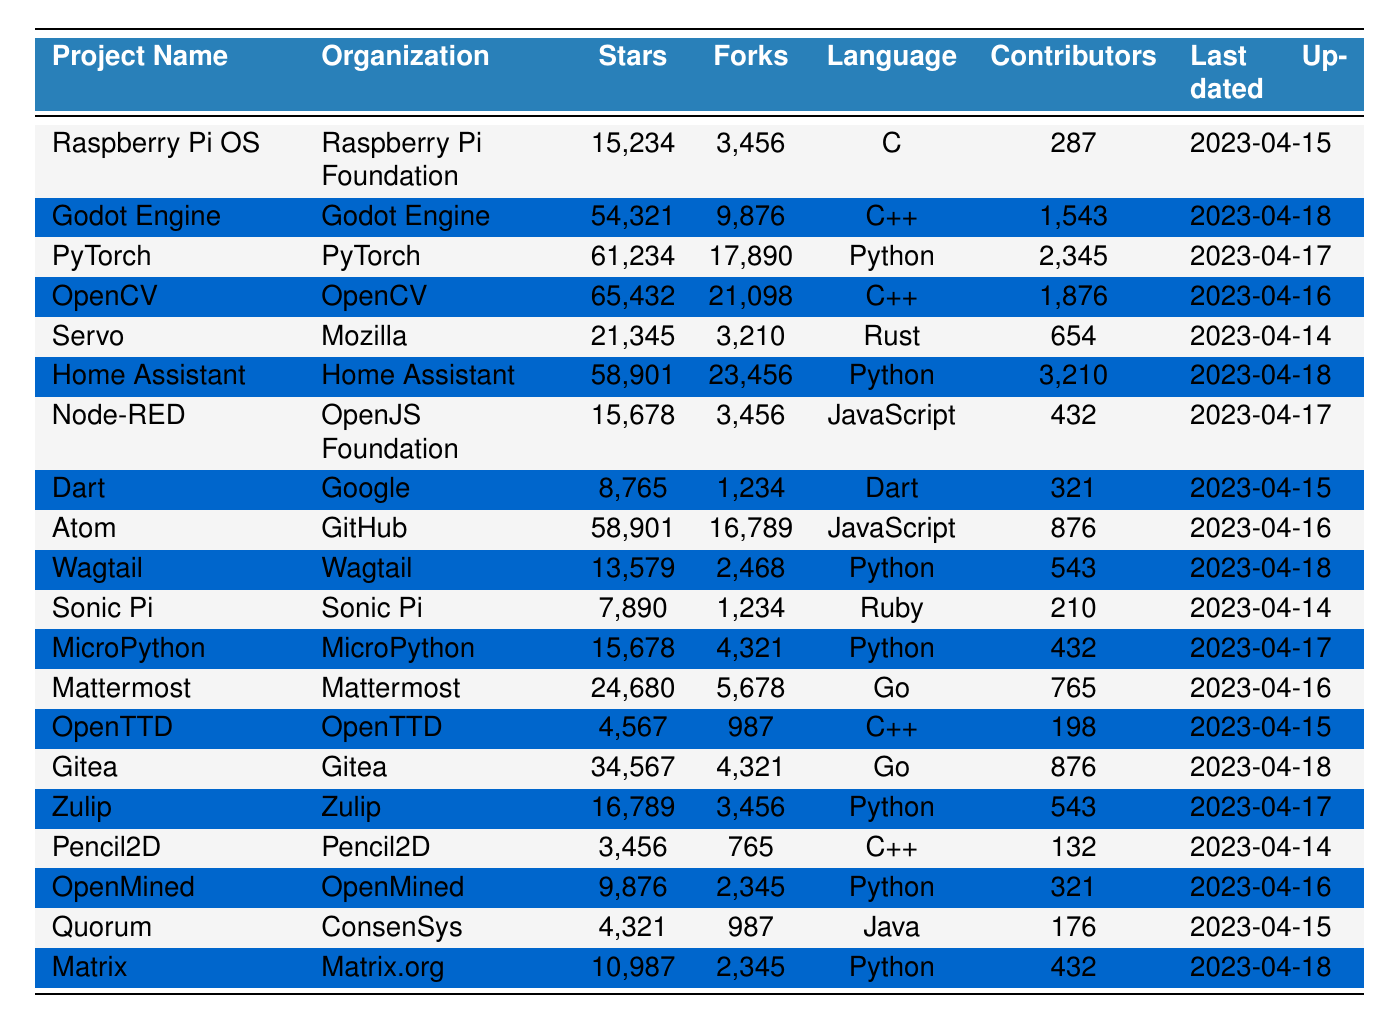What is the project with the highest number of GitHub stars? The project with the highest number of GitHub stars can be found by looking for the maximum value in the "Stars" column. The highest value is 61,234, which corresponds to the project "PyTorch."
Answer: PyTorch How many contributors does the project "Home Assistant" have? The number of contributors for "Home Assistant" can be directly found in the "Contributors" column next to the project name. It lists 3,210 contributors.
Answer: 3210 Which programming language is most frequently used among these projects? By looking at the "Language" column, we can count the occurrences of each programming language. Python appears the most often across multiple projects.
Answer: Python What is the total number of forks for all projects listed in the table? To find the total number of forks, sum the values in the "Forks" column: 3,456 + 9,876 + 17,890 + 21,098 + ... + 987 + 2,345. The total is 106,892 forks.
Answer: 106892 Is "Atom" more popular than "Node-RED" based on GitHub stars? To determine if "Atom" is more popular than "Node-RED", we compare their star counts: "Atom" has 58,901 stars and "Node-RED" has 15,678 stars. Since 58,901 is greater than 15,678, "Atom" is more popular.
Answer: Yes What is the median number of forks among the projects? To find the median, we first need to list the number of forks in ascending order: 765, 987, 1,234, 3,210, 3,456, ..., 21,098. There are 20 projects, so the median will be the average of the 10th and 11th values in this ordered list. Adding those values gives 17,010, and dividing by 2 gives 8,505.
Answer: 8505 Which project has the least contributors and what is the number? We check the "Contributors" column for the lowest value. The project with the least contributors is "Pencil2D" with 132 contributors.
Answer: Pencil2D, 132 How many projects use C++ as their primary language? By scanning the "Language" column, we can count the number of projects that have "C++" as their primary language. There are 5 such projects.
Answer: 5 What is the difference in GitHub stars between "OpenCV" and "Dart"? The stars for "OpenCV" are 65,432 and for "Dart" they are 8,765. Subtracting gives us 65,432 - 8,765 = 56,667 stars.
Answer: 56667 Are there more projects with over 20,000 stars or under 20,000 stars? We categorize the projects based on their star counts visible in the table. There are 10 projects with over 20,000 stars and 10 projects with under 20,000 stars, making the counts equal.
Answer: Equal 